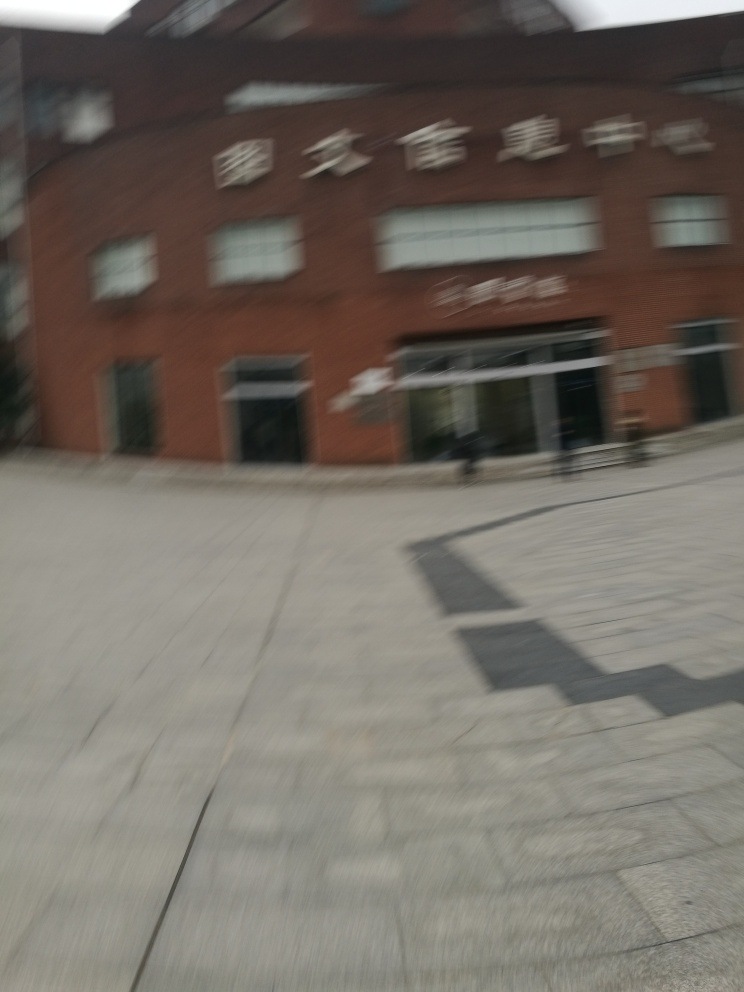Can you describe the architecture of the building? Despite the blurring, it can be observed that the building exhibits a modern architectural style with what looks like a brick facade. The signage and large glass windows suggest a design that caters to public engagement, typical of buildings intended for businesses or public services. 